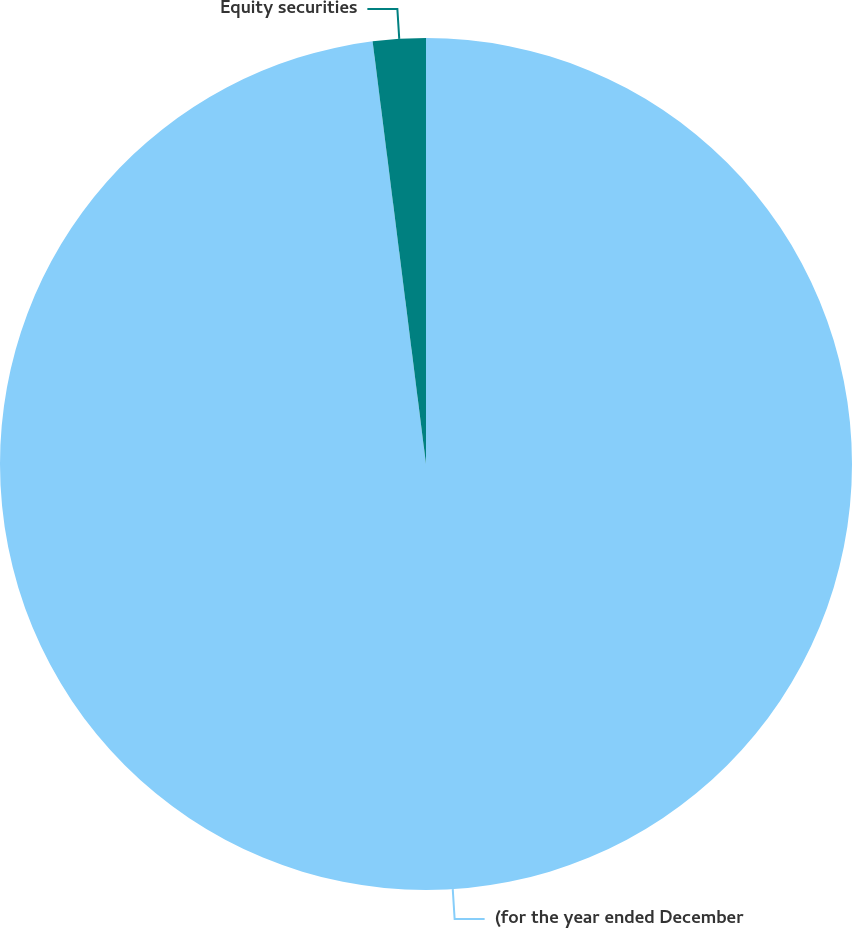<chart> <loc_0><loc_0><loc_500><loc_500><pie_chart><fcel>(for the year ended December<fcel>Equity securities<nl><fcel>98.0%<fcel>2.0%<nl></chart> 